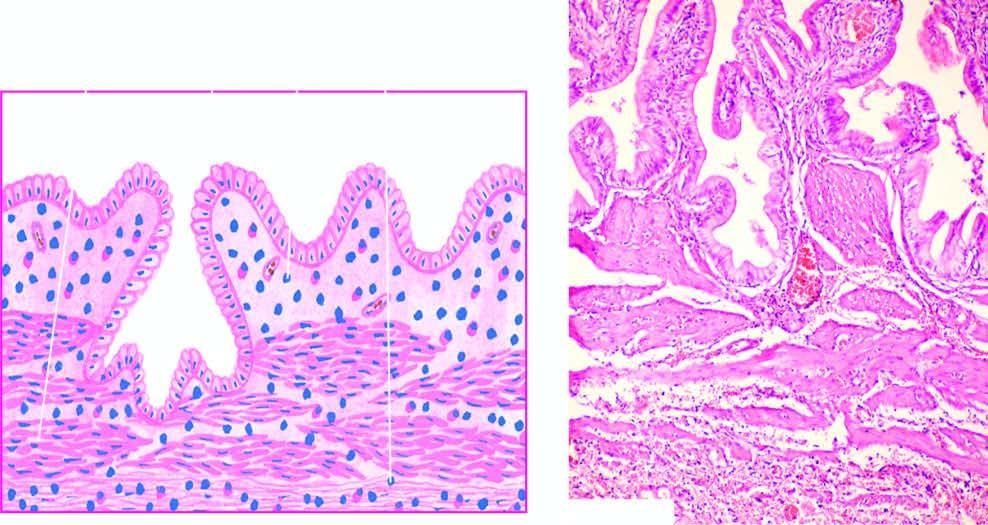what is present in subepithelial and perimuscular layers?
Answer the question using a single word or phrase. Mononuclear inflammatory cell infiltrate 